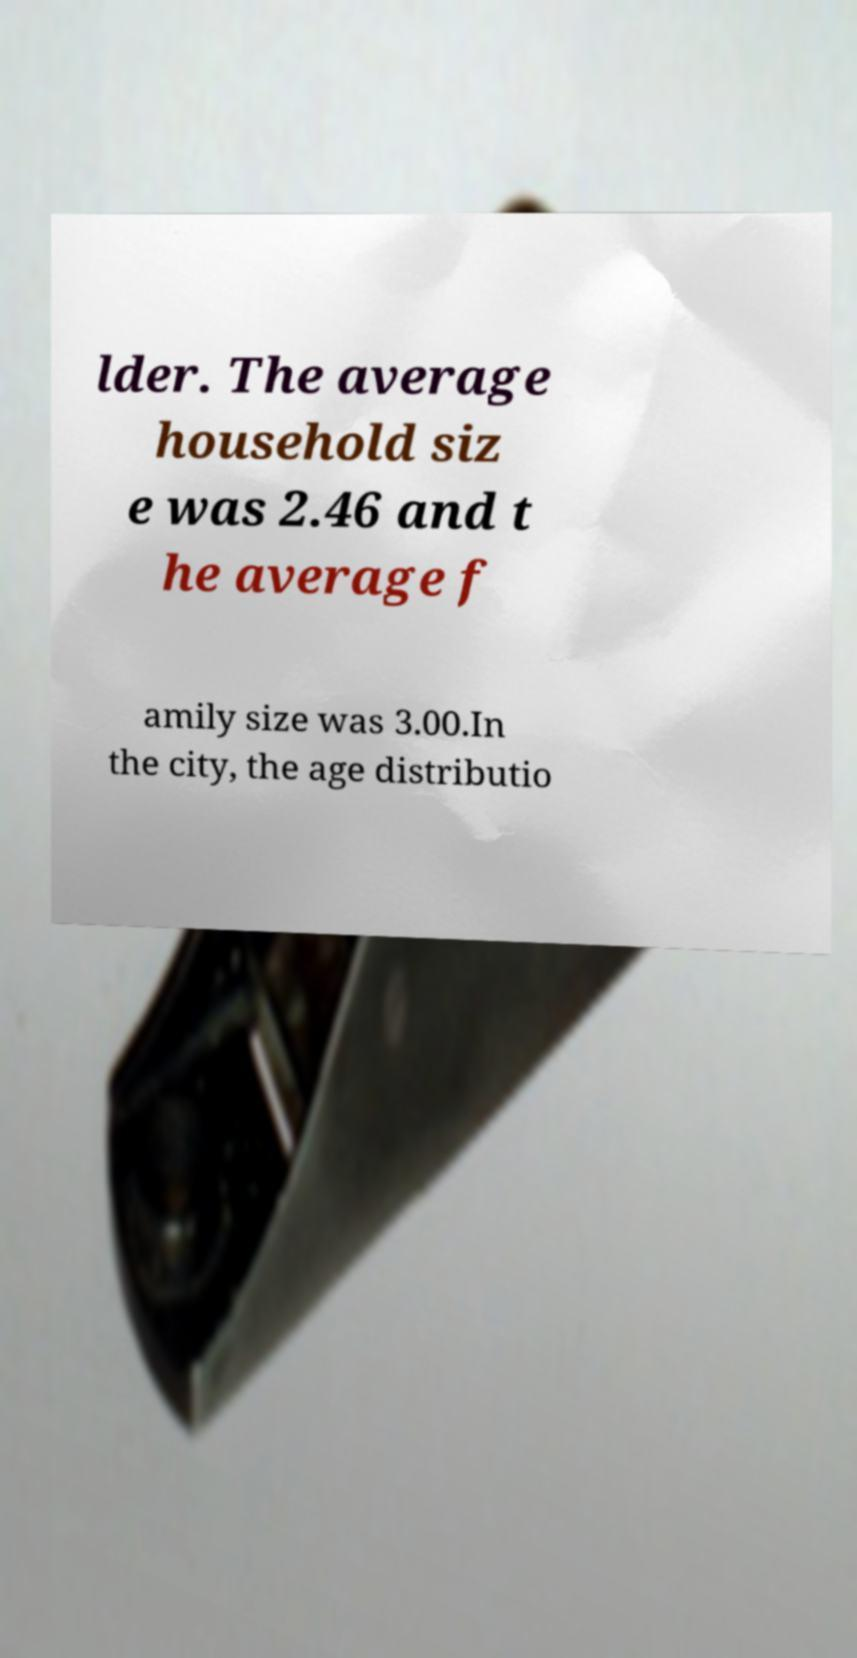Can you read and provide the text displayed in the image?This photo seems to have some interesting text. Can you extract and type it out for me? lder. The average household siz e was 2.46 and t he average f amily size was 3.00.In the city, the age distributio 